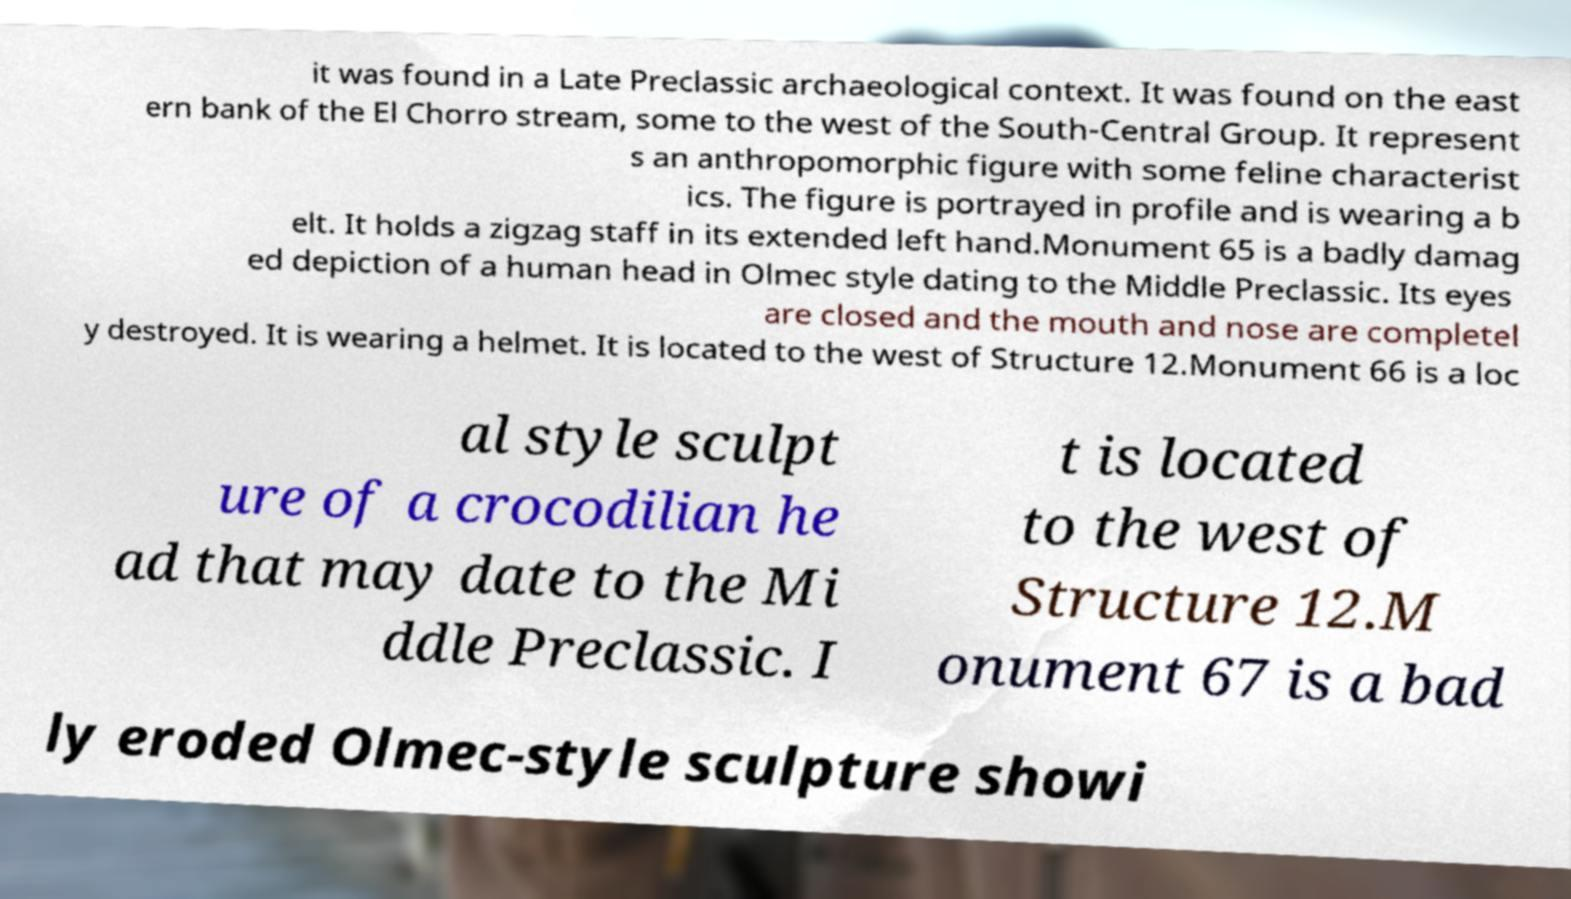Could you assist in decoding the text presented in this image and type it out clearly? it was found in a Late Preclassic archaeological context. It was found on the east ern bank of the El Chorro stream, some to the west of the South-Central Group. It represent s an anthropomorphic figure with some feline characterist ics. The figure is portrayed in profile and is wearing a b elt. It holds a zigzag staff in its extended left hand.Monument 65 is a badly damag ed depiction of a human head in Olmec style dating to the Middle Preclassic. Its eyes are closed and the mouth and nose are completel y destroyed. It is wearing a helmet. It is located to the west of Structure 12.Monument 66 is a loc al style sculpt ure of a crocodilian he ad that may date to the Mi ddle Preclassic. I t is located to the west of Structure 12.M onument 67 is a bad ly eroded Olmec-style sculpture showi 